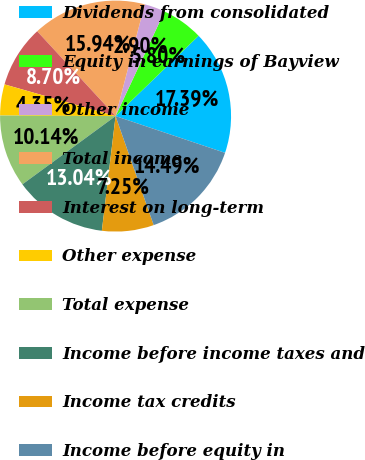Convert chart. <chart><loc_0><loc_0><loc_500><loc_500><pie_chart><fcel>Dividends from consolidated<fcel>Equity in earnings of Bayview<fcel>Other income<fcel>Total income<fcel>Interest on long-term<fcel>Other expense<fcel>Total expense<fcel>Income before income taxes and<fcel>Income tax credits<fcel>Income before equity in<nl><fcel>17.39%<fcel>5.8%<fcel>2.9%<fcel>15.94%<fcel>8.7%<fcel>4.35%<fcel>10.14%<fcel>13.04%<fcel>7.25%<fcel>14.49%<nl></chart> 